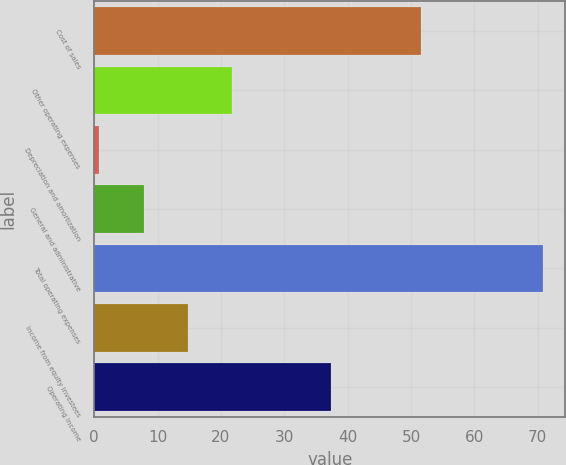<chart> <loc_0><loc_0><loc_500><loc_500><bar_chart><fcel>Cost of sales<fcel>Other operating expenses<fcel>Depreciation and amortization<fcel>General and administrative<fcel>Total operating expenses<fcel>Income from equity investees<fcel>Operating income<nl><fcel>51.5<fcel>21.8<fcel>0.8<fcel>7.8<fcel>70.8<fcel>14.8<fcel>37.3<nl></chart> 